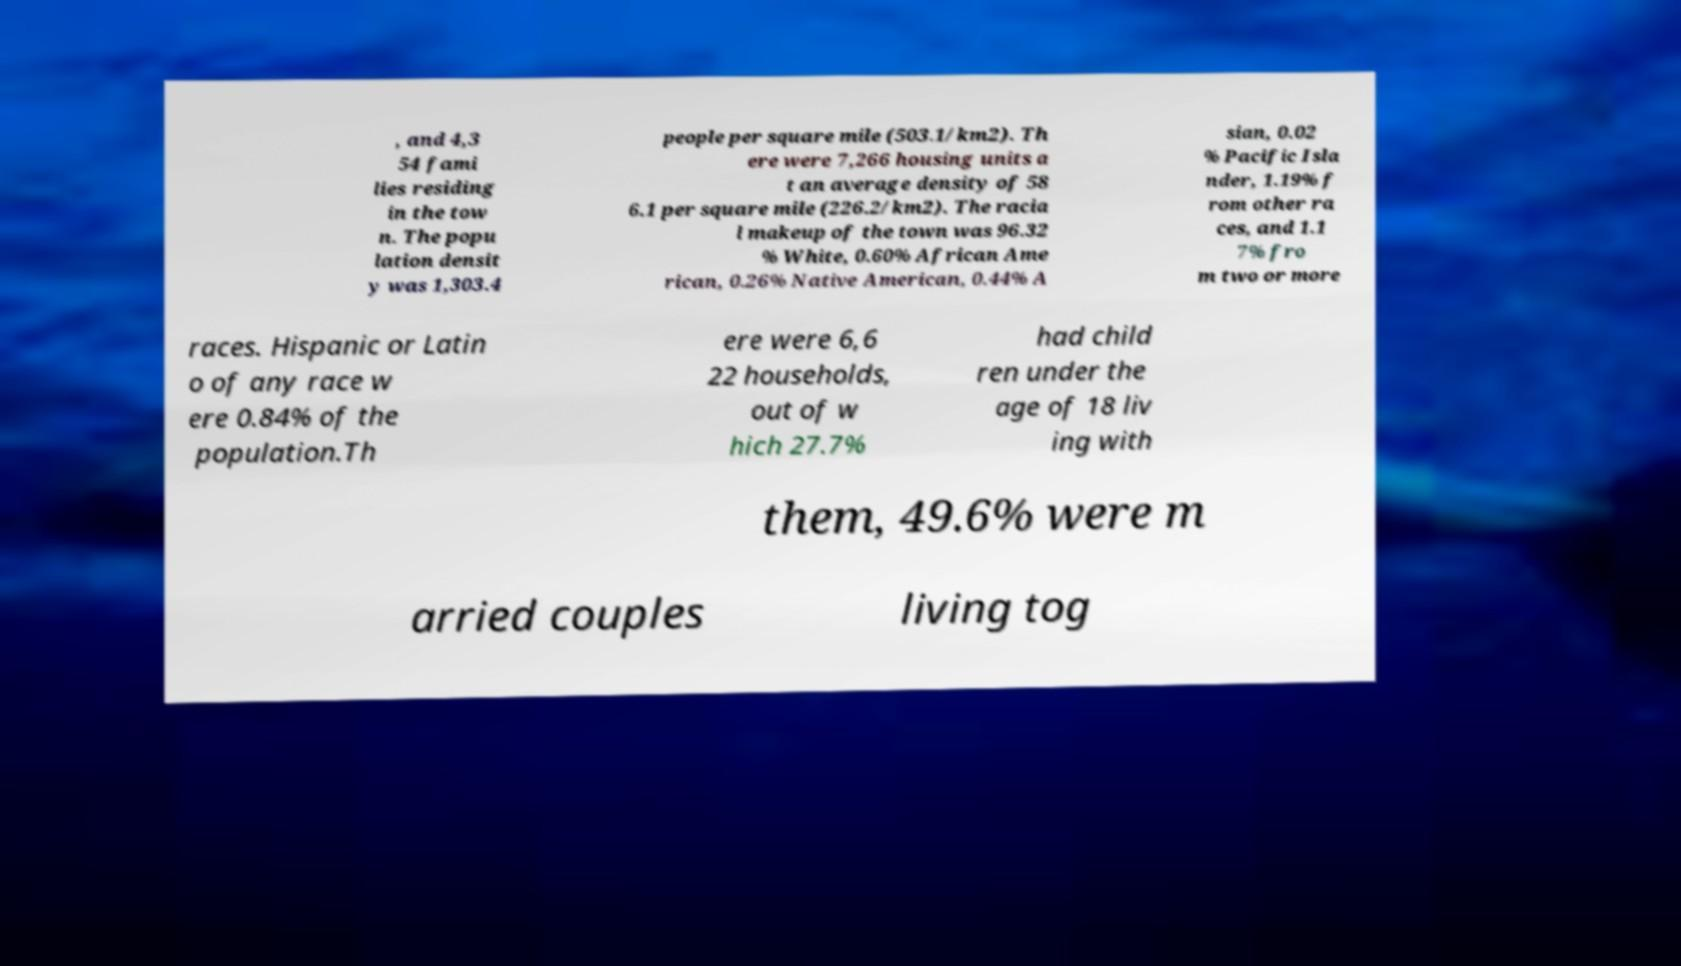Could you extract and type out the text from this image? , and 4,3 54 fami lies residing in the tow n. The popu lation densit y was 1,303.4 people per square mile (503.1/km2). Th ere were 7,266 housing units a t an average density of 58 6.1 per square mile (226.2/km2). The racia l makeup of the town was 96.32 % White, 0.60% African Ame rican, 0.26% Native American, 0.44% A sian, 0.02 % Pacific Isla nder, 1.19% f rom other ra ces, and 1.1 7% fro m two or more races. Hispanic or Latin o of any race w ere 0.84% of the population.Th ere were 6,6 22 households, out of w hich 27.7% had child ren under the age of 18 liv ing with them, 49.6% were m arried couples living tog 